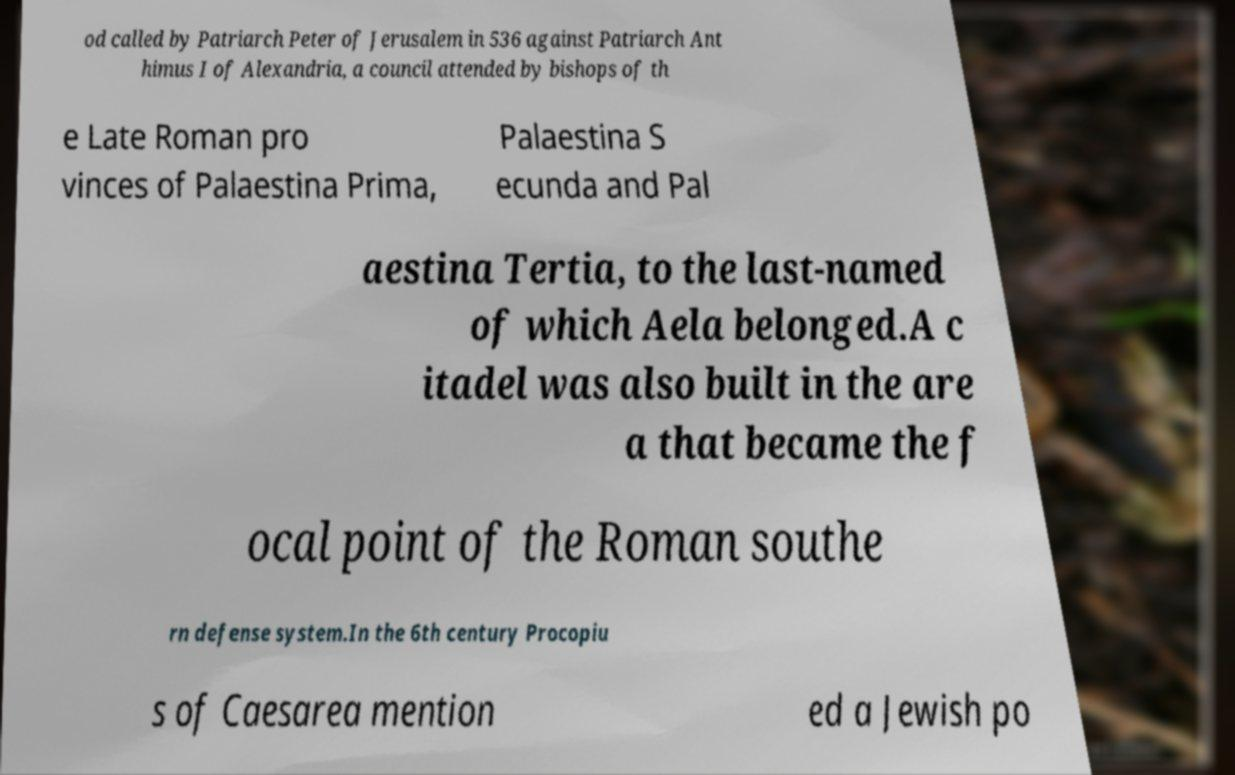Please identify and transcribe the text found in this image. od called by Patriarch Peter of Jerusalem in 536 against Patriarch Ant himus I of Alexandria, a council attended by bishops of th e Late Roman pro vinces of Palaestina Prima, Palaestina S ecunda and Pal aestina Tertia, to the last-named of which Aela belonged.A c itadel was also built in the are a that became the f ocal point of the Roman southe rn defense system.In the 6th century Procopiu s of Caesarea mention ed a Jewish po 